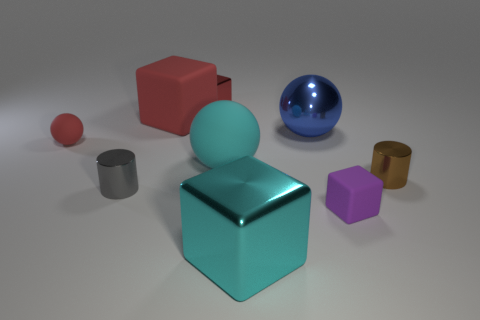What is the color of the large ball behind the big rubber object on the right side of the tiny red block behind the cyan metal object? The large ball situated behind the rubber object, which is to the right of the small red block that is itself behind the cyan metal object, is colored blue. Its glossy surface suggests it could be a material like plastic or polished metal. 